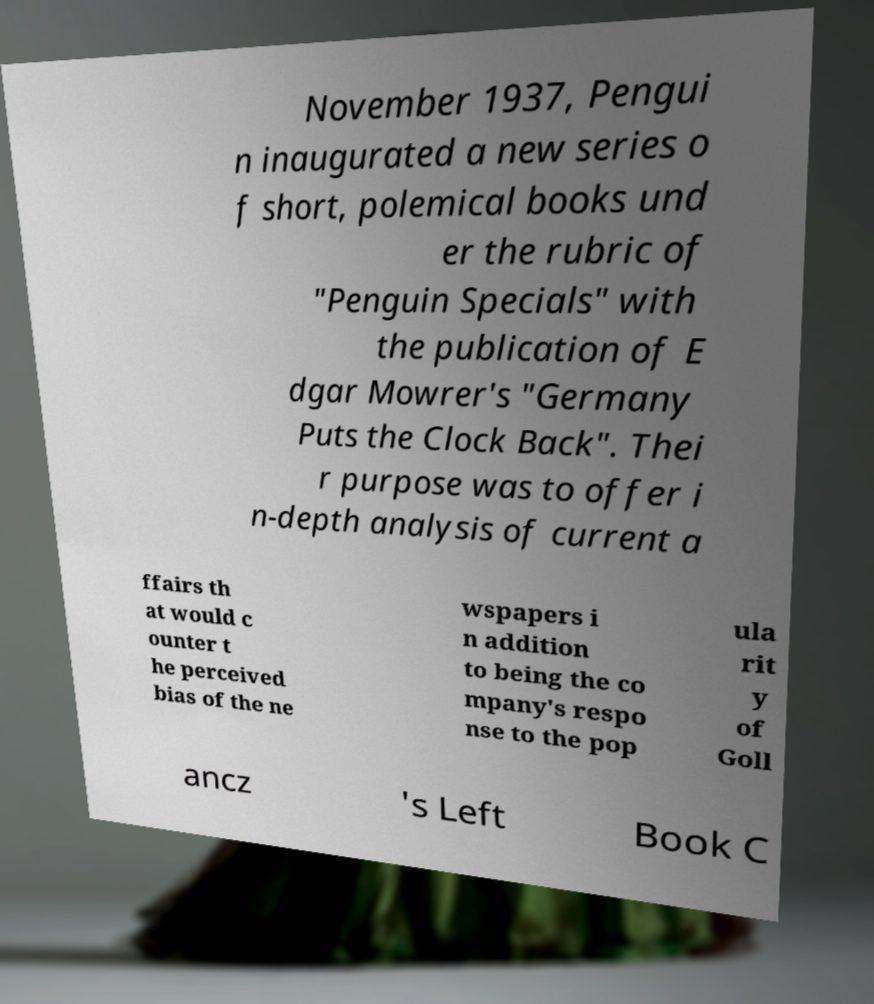For documentation purposes, I need the text within this image transcribed. Could you provide that? November 1937, Pengui n inaugurated a new series o f short, polemical books und er the rubric of "Penguin Specials" with the publication of E dgar Mowrer's "Germany Puts the Clock Back". Thei r purpose was to offer i n-depth analysis of current a ffairs th at would c ounter t he perceived bias of the ne wspapers i n addition to being the co mpany's respo nse to the pop ula rit y of Goll ancz 's Left Book C 